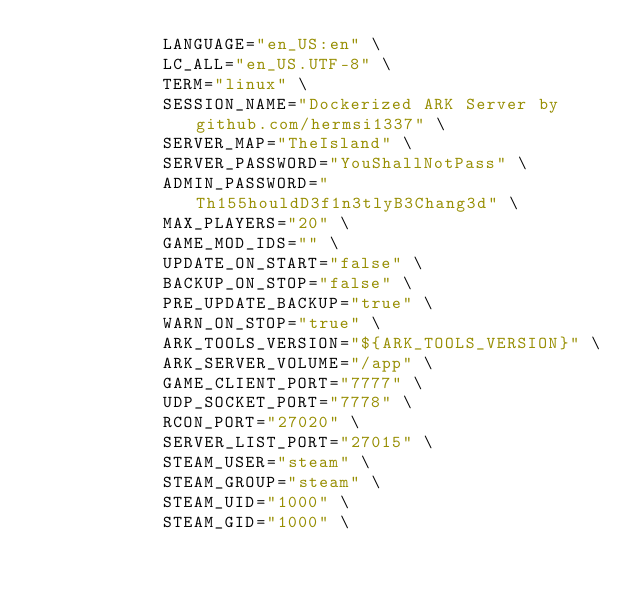Convert code to text. <code><loc_0><loc_0><loc_500><loc_500><_Dockerfile_>            LANGUAGE="en_US:en" \
            LC_ALL="en_US.UTF-8" \
            TERM="linux" \
            SESSION_NAME="Dockerized ARK Server by github.com/hermsi1337" \
            SERVER_MAP="TheIsland" \
            SERVER_PASSWORD="YouShallNotPass" \
            ADMIN_PASSWORD="Th155houldD3f1n3tlyB3Chang3d" \
            MAX_PLAYERS="20" \
            GAME_MOD_IDS="" \
            UPDATE_ON_START="false" \
            BACKUP_ON_STOP="false" \
            PRE_UPDATE_BACKUP="true" \
            WARN_ON_STOP="true" \
            ARK_TOOLS_VERSION="${ARK_TOOLS_VERSION}" \
            ARK_SERVER_VOLUME="/app" \
            GAME_CLIENT_PORT="7777" \
            UDP_SOCKET_PORT="7778" \
            RCON_PORT="27020" \
            SERVER_LIST_PORT="27015" \
            STEAM_USER="steam" \
            STEAM_GROUP="steam" \
            STEAM_UID="1000" \
            STEAM_GID="1000" \</code> 